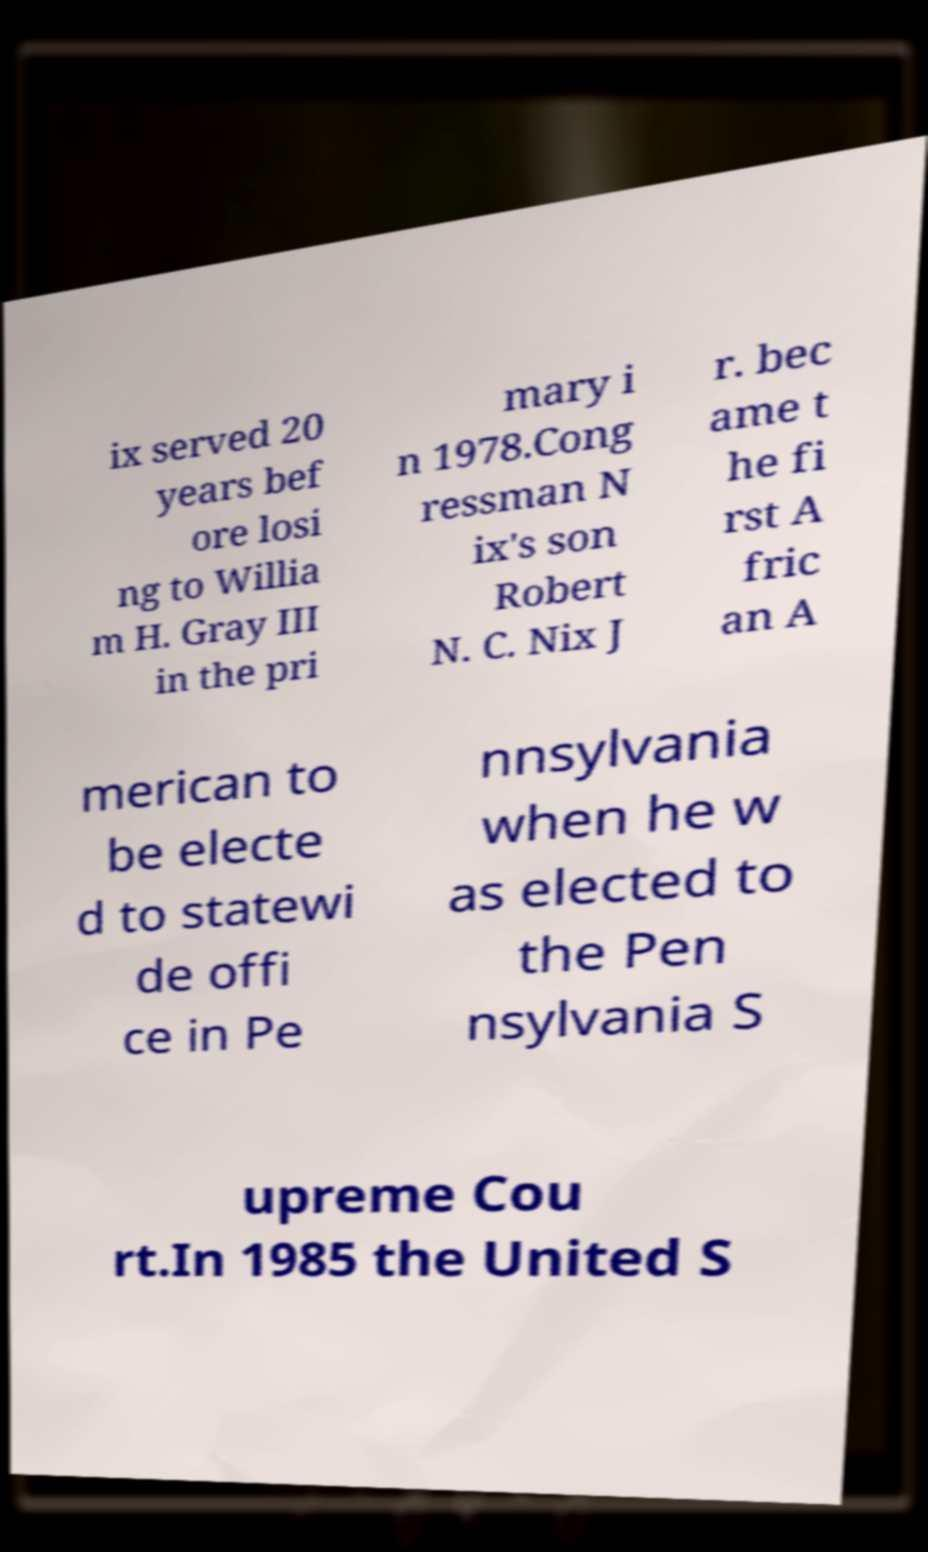For documentation purposes, I need the text within this image transcribed. Could you provide that? ix served 20 years bef ore losi ng to Willia m H. Gray III in the pri mary i n 1978.Cong ressman N ix's son Robert N. C. Nix J r. bec ame t he fi rst A fric an A merican to be electe d to statewi de offi ce in Pe nnsylvania when he w as elected to the Pen nsylvania S upreme Cou rt.In 1985 the United S 